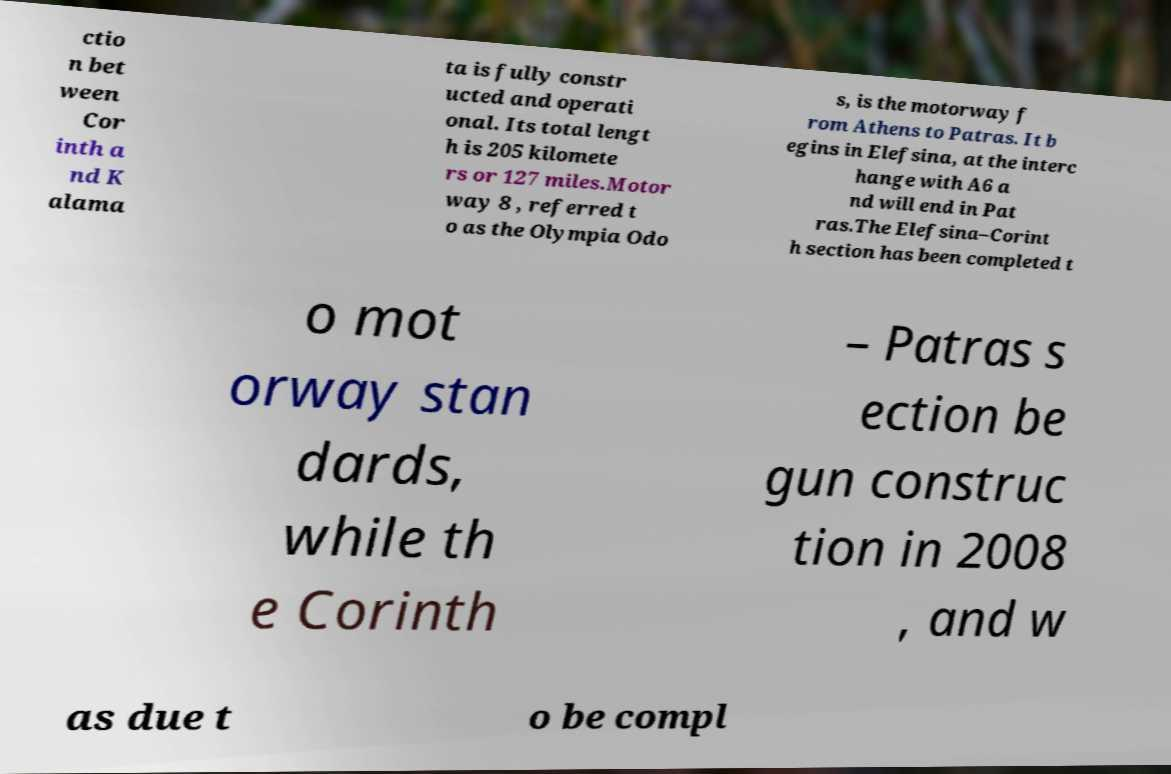I need the written content from this picture converted into text. Can you do that? ctio n bet ween Cor inth a nd K alama ta is fully constr ucted and operati onal. Its total lengt h is 205 kilomete rs or 127 miles.Motor way 8 , referred t o as the Olympia Odo s, is the motorway f rom Athens to Patras. It b egins in Elefsina, at the interc hange with A6 a nd will end in Pat ras.The Elefsina–Corint h section has been completed t o mot orway stan dards, while th e Corinth – Patras s ection be gun construc tion in 2008 , and w as due t o be compl 